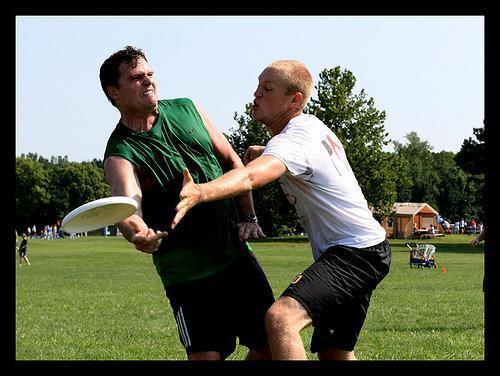How many people are playing?
Give a very brief answer. 2. How many people are in the picture?
Give a very brief answer. 2. 